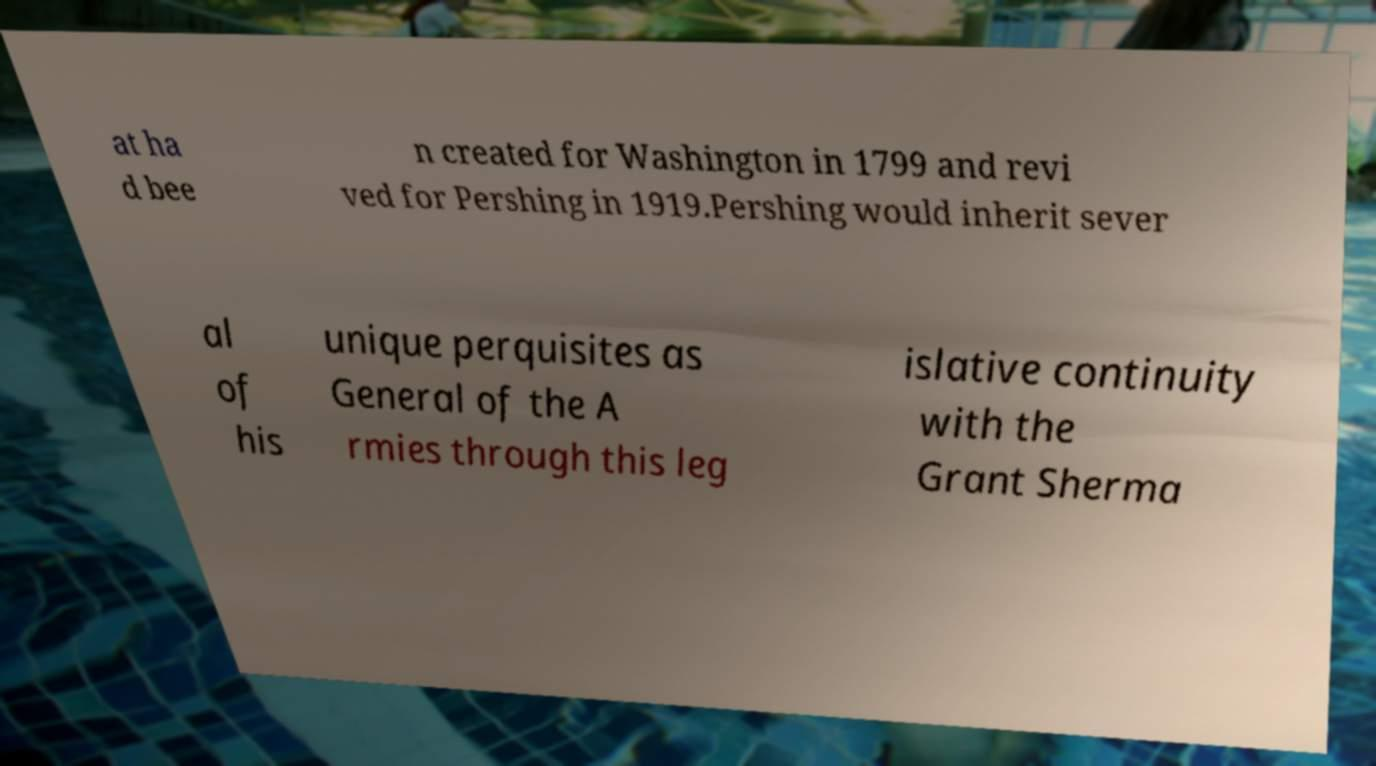Could you assist in decoding the text presented in this image and type it out clearly? at ha d bee n created for Washington in 1799 and revi ved for Pershing in 1919.Pershing would inherit sever al of his unique perquisites as General of the A rmies through this leg islative continuity with the Grant Sherma 